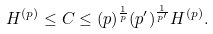<formula> <loc_0><loc_0><loc_500><loc_500>H ^ { ( p ) } \leq C \leq ( p ) ^ { \frac { 1 } { p } } ( p ^ { \prime } ) ^ { \frac { 1 } { p ^ { \prime } } } H ^ { ( p ) } .</formula> 